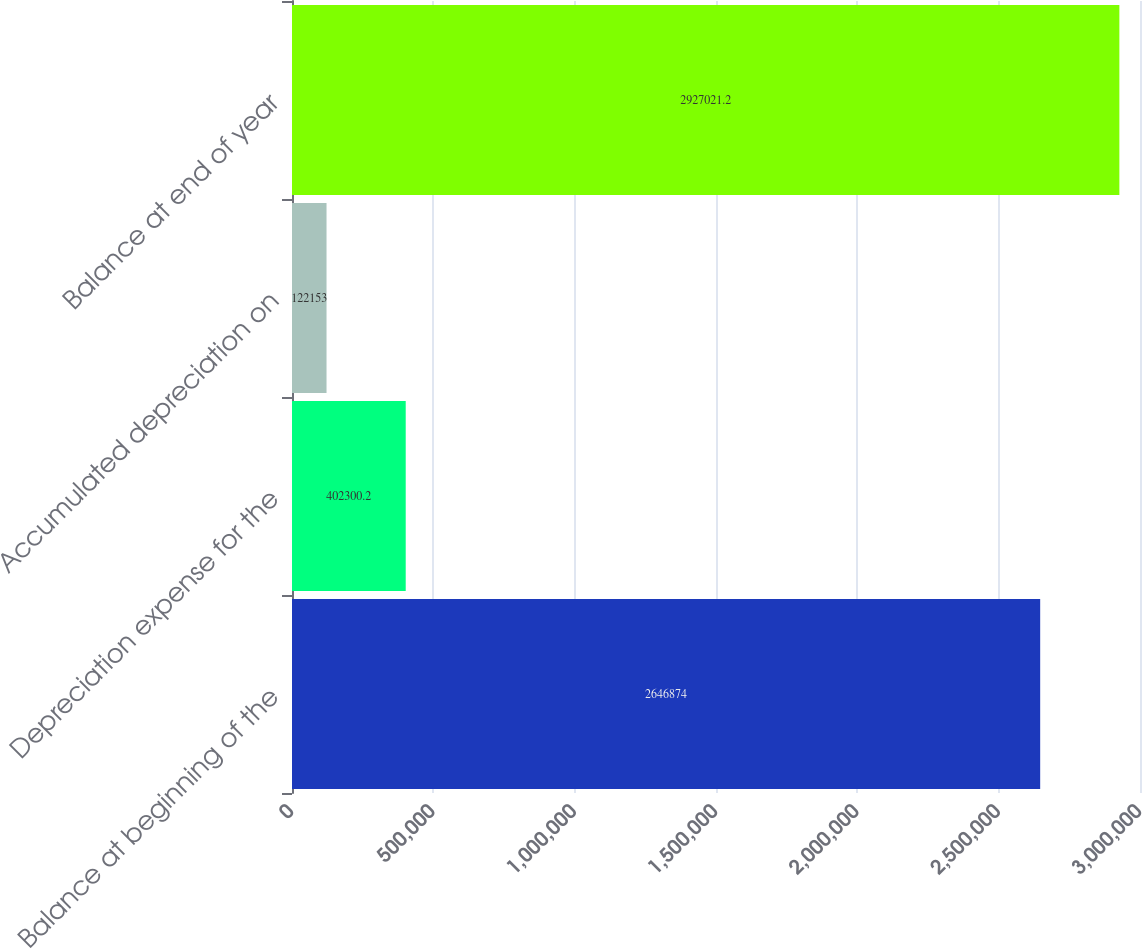Convert chart. <chart><loc_0><loc_0><loc_500><loc_500><bar_chart><fcel>Balance at beginning of the<fcel>Depreciation expense for the<fcel>Accumulated depreciation on<fcel>Balance at end of year<nl><fcel>2.64687e+06<fcel>402300<fcel>122153<fcel>2.92702e+06<nl></chart> 